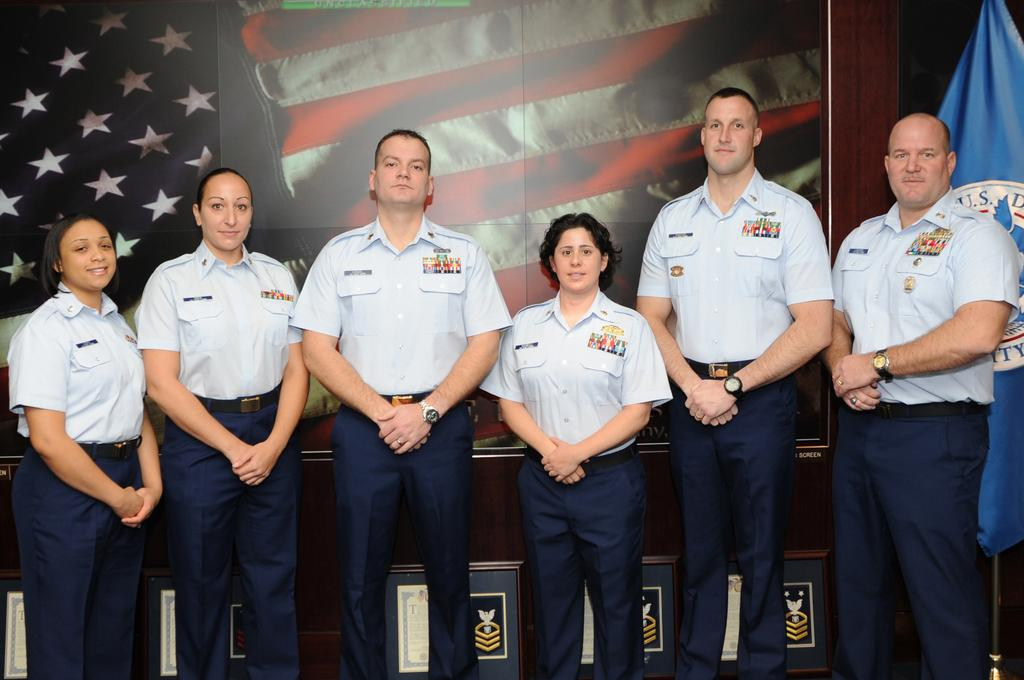Who or what is present in the image? There are people in the image. What are the people wearing? The people are wearing the same uniform. What are the people doing in the image? The people are standing. What can be seen in the background of the image? There are posters in the background of the image. What type of impulse can be seen affecting the people in the image? There is no impulse affecting the people in the image; they are simply standing. What kind of shock is visible on the faces of the people in the image? There is no shock visible on the faces of the people in the image; they appear to be standing calmly. 